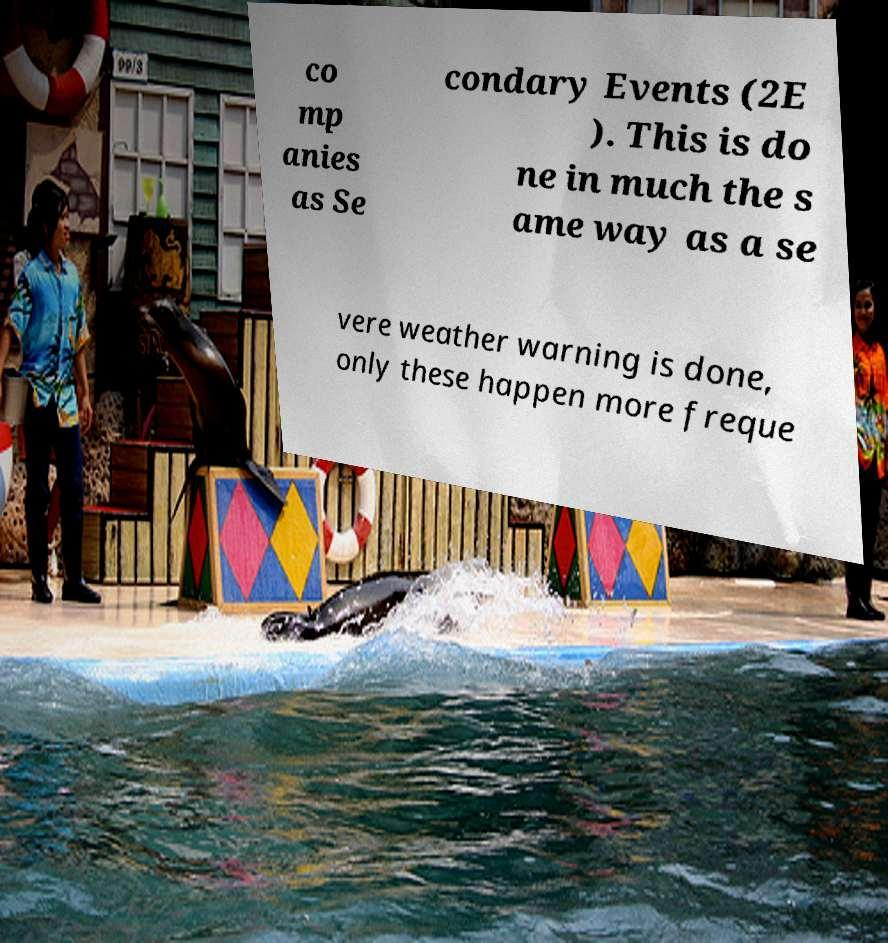Could you extract and type out the text from this image? co mp anies as Se condary Events (2E ). This is do ne in much the s ame way as a se vere weather warning is done, only these happen more freque 